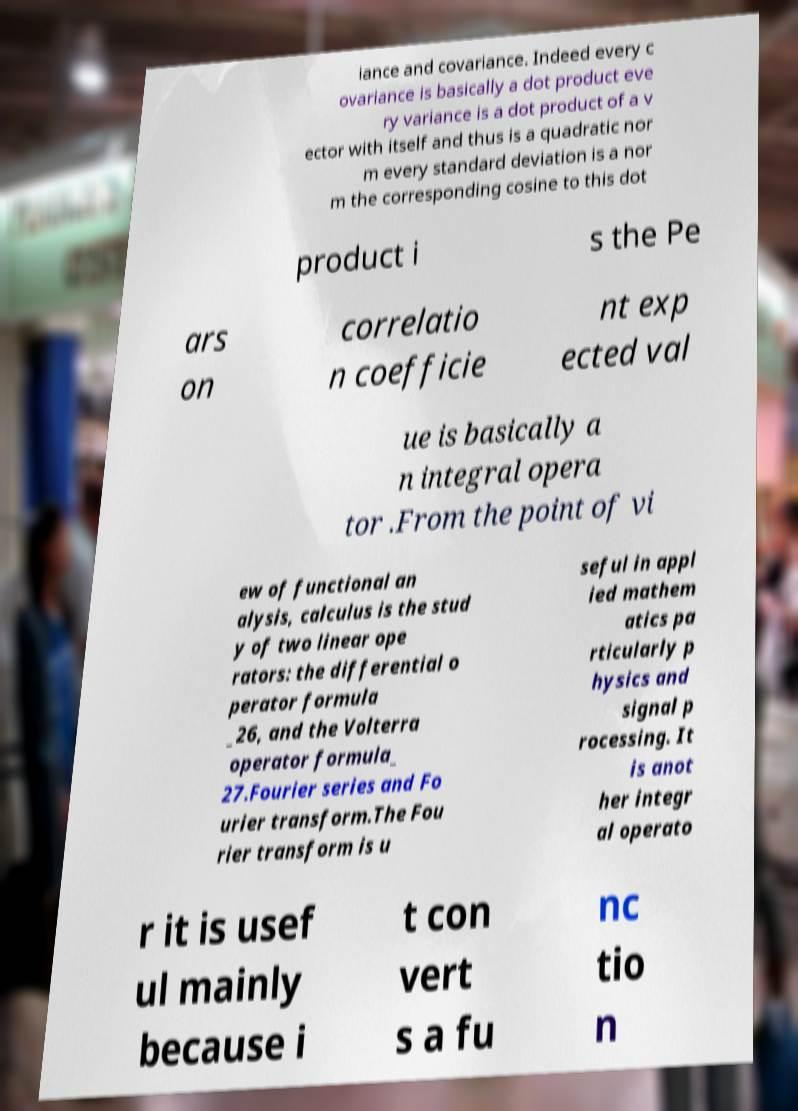Please identify and transcribe the text found in this image. iance and covariance. Indeed every c ovariance is basically a dot product eve ry variance is a dot product of a v ector with itself and thus is a quadratic nor m every standard deviation is a nor m the corresponding cosine to this dot product i s the Pe ars on correlatio n coefficie nt exp ected val ue is basically a n integral opera tor .From the point of vi ew of functional an alysis, calculus is the stud y of two linear ope rators: the differential o perator formula _26, and the Volterra operator formula_ 27.Fourier series and Fo urier transform.The Fou rier transform is u seful in appl ied mathem atics pa rticularly p hysics and signal p rocessing. It is anot her integr al operato r it is usef ul mainly because i t con vert s a fu nc tio n 